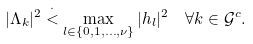Convert formula to latex. <formula><loc_0><loc_0><loc_500><loc_500>| \Lambda _ { k } | ^ { 2 } & \stackrel { \cdot } { < } \max _ { l \in \{ 0 , 1 , \dots , \nu \} } | h _ { l } | ^ { 2 } \quad \forall k \in \mathcal { G } ^ { c } .</formula> 